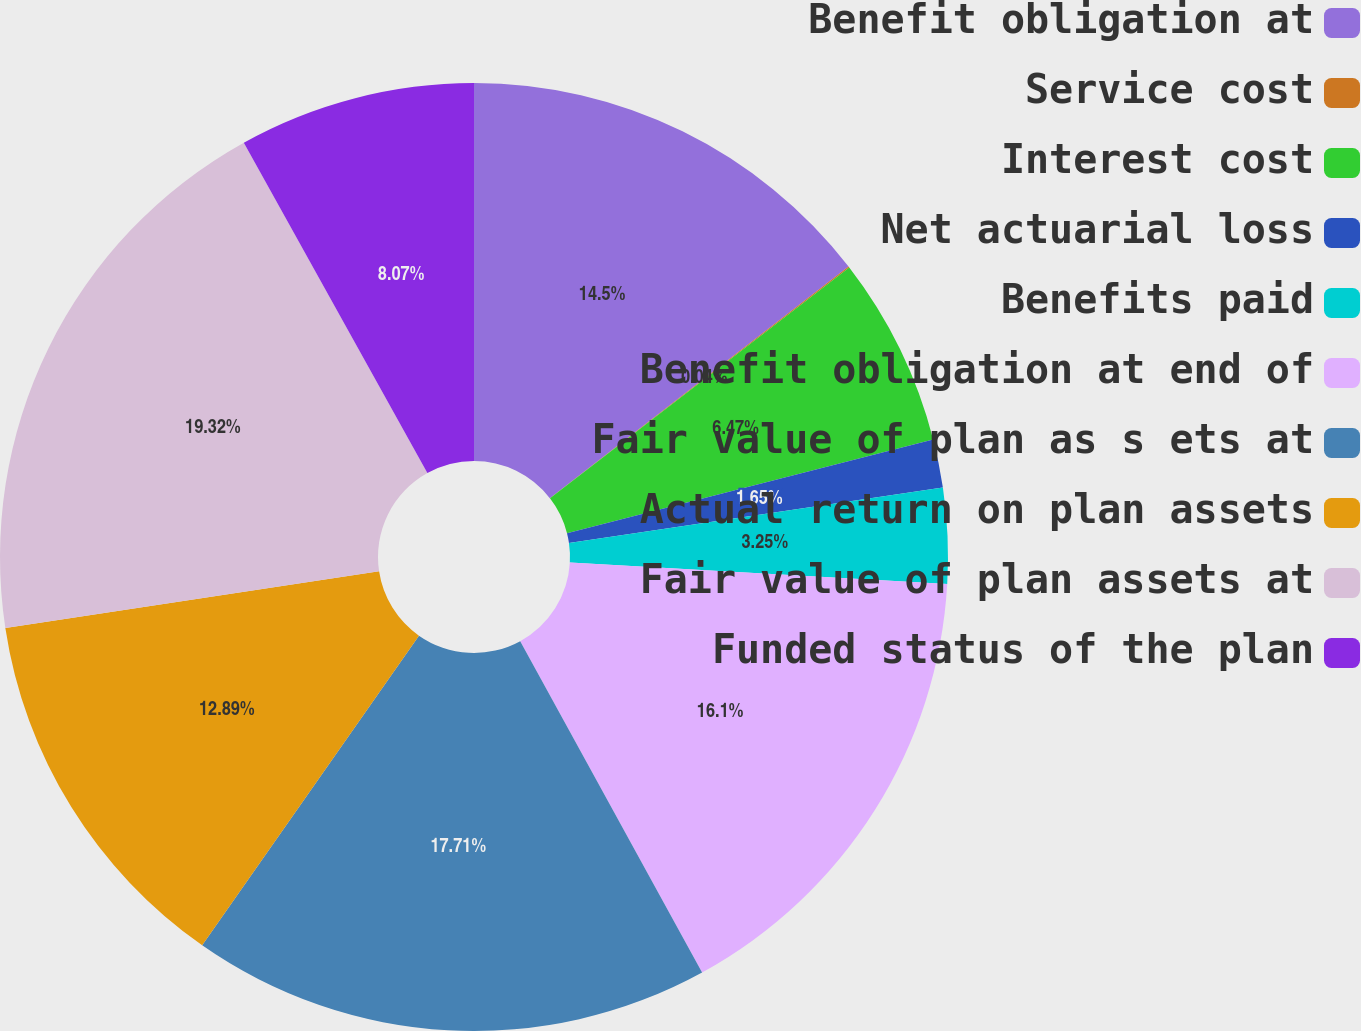Convert chart to OTSL. <chart><loc_0><loc_0><loc_500><loc_500><pie_chart><fcel>Benefit obligation at<fcel>Service cost<fcel>Interest cost<fcel>Net actuarial loss<fcel>Benefits paid<fcel>Benefit obligation at end of<fcel>Fair value of plan as s ets at<fcel>Actual return on plan assets<fcel>Fair value of plan assets at<fcel>Funded status of the plan<nl><fcel>14.5%<fcel>0.04%<fcel>6.47%<fcel>1.65%<fcel>3.25%<fcel>16.1%<fcel>17.71%<fcel>12.89%<fcel>19.32%<fcel>8.07%<nl></chart> 